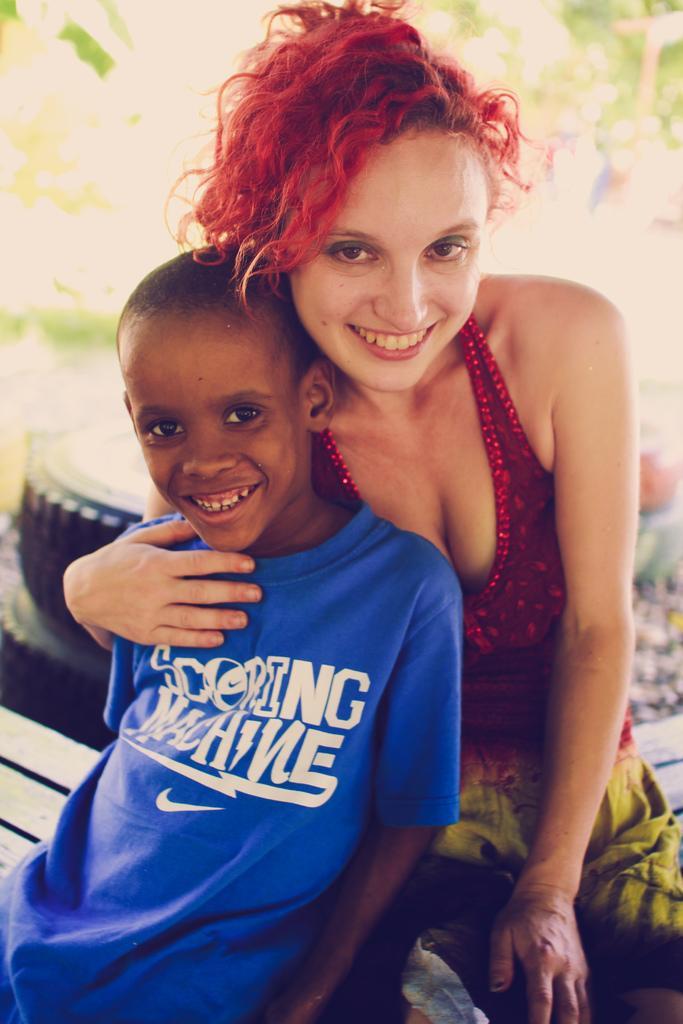How would you summarize this image in a sentence or two? In this image we can see a kid, and a lady, sitting on the wooden desk, behind them there are tyres, and the background is blurred. 